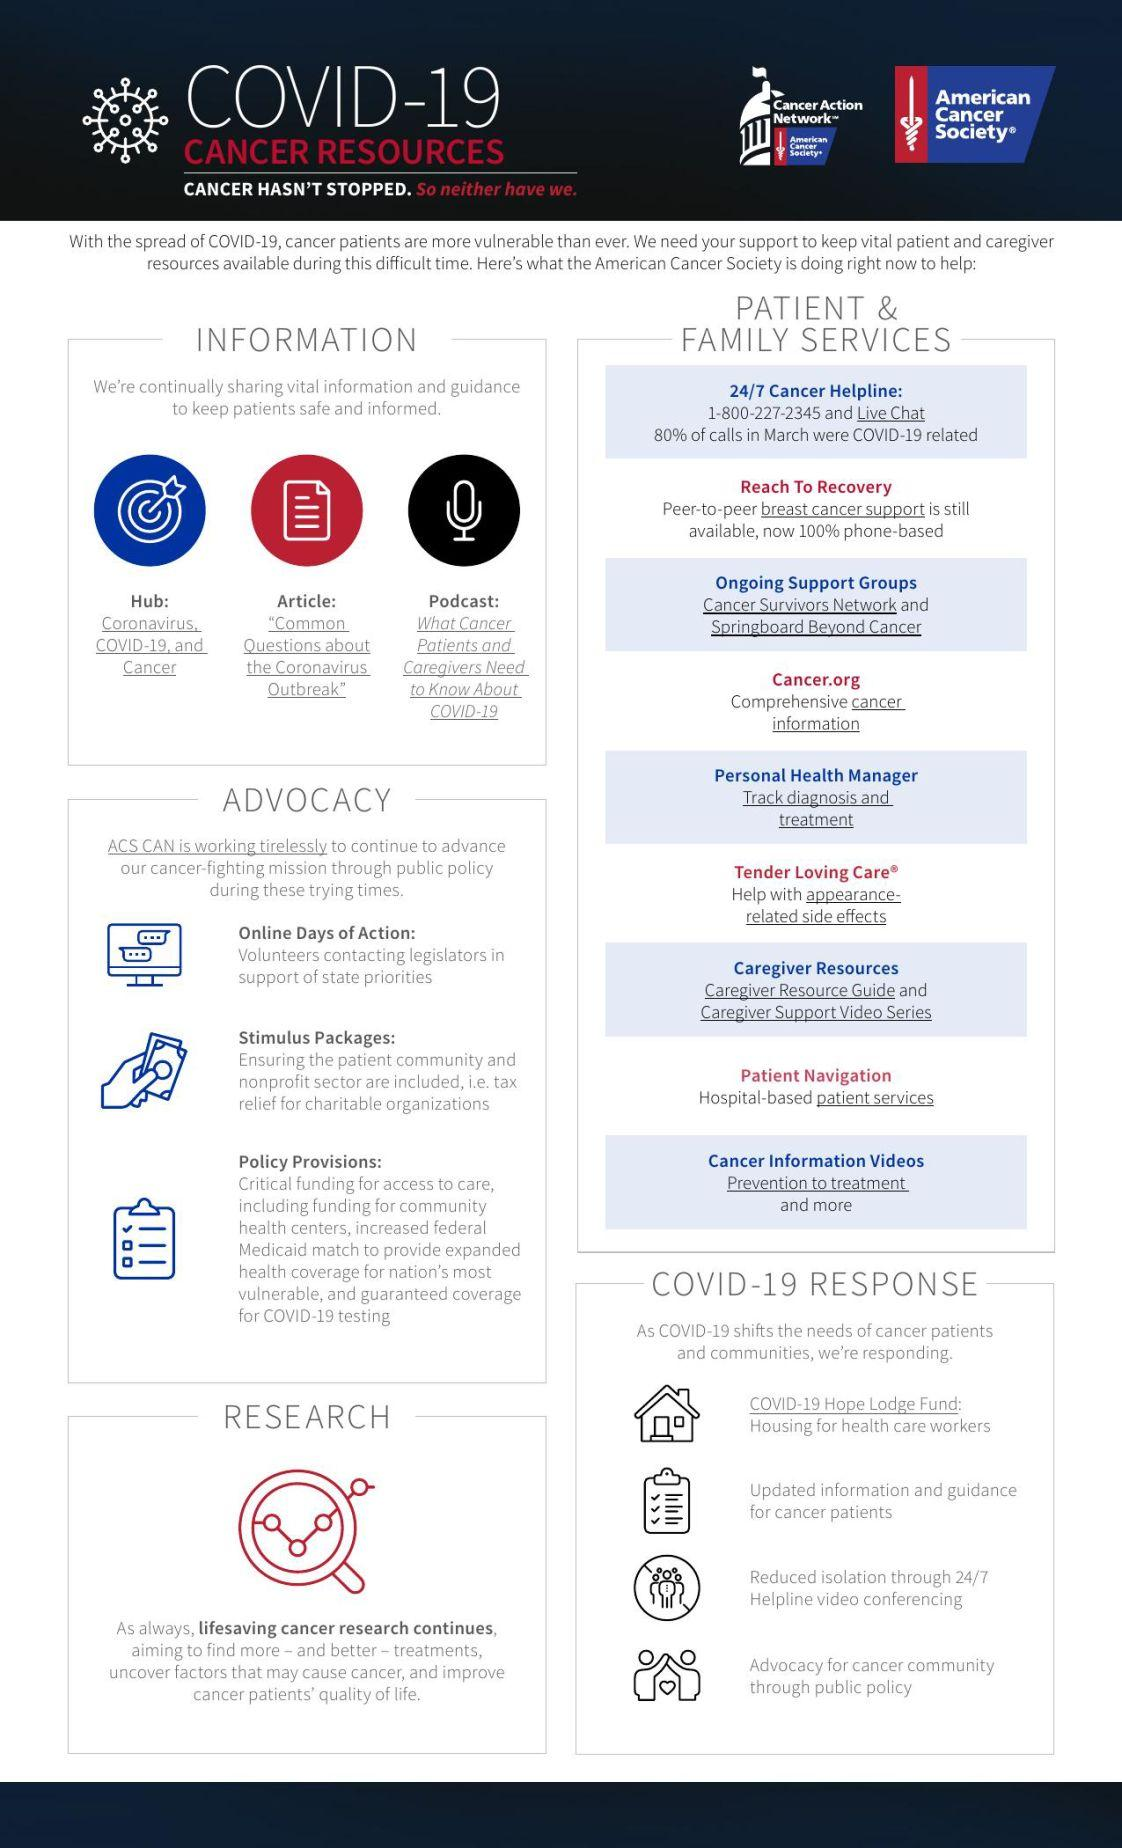Specify some key components in this picture. There are three points under the heading of Advocacy. The number of points listed under the heading 'Patient & Family Services' is 9. 